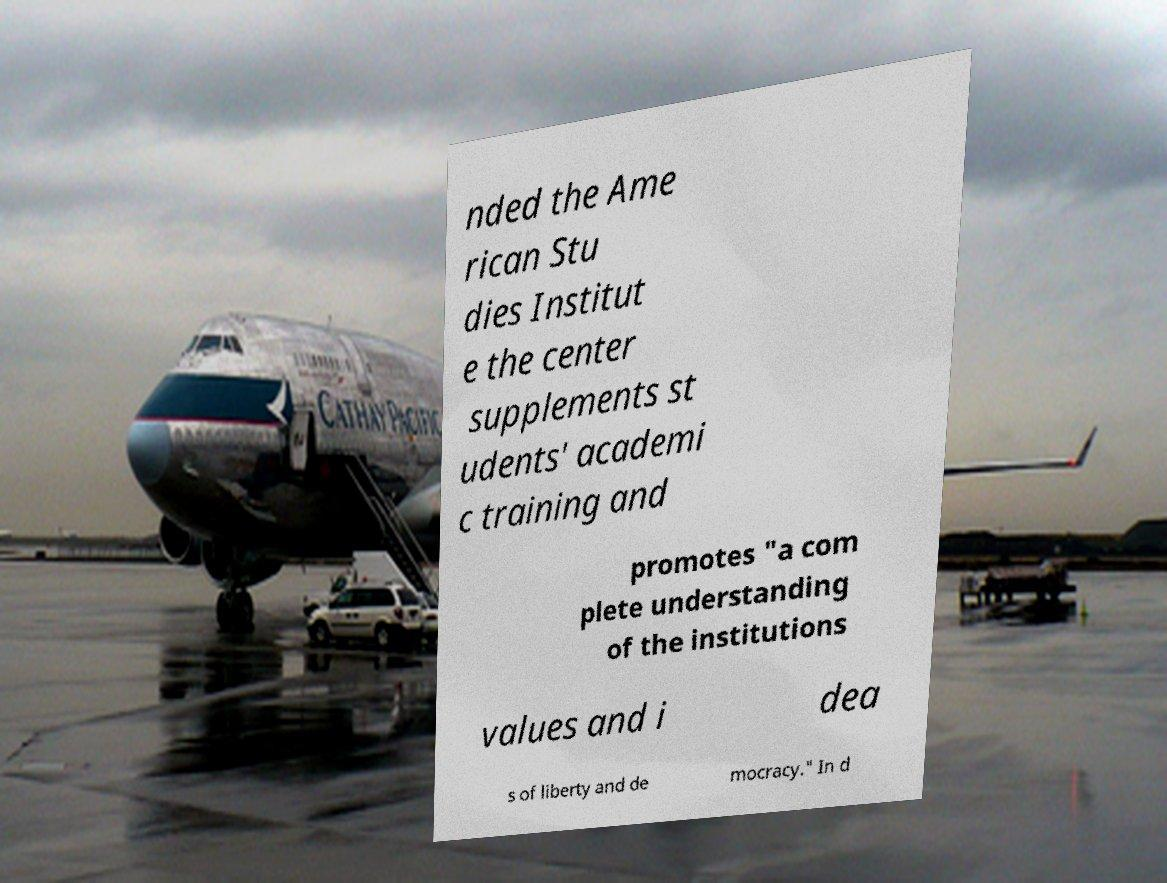Can you accurately transcribe the text from the provided image for me? nded the Ame rican Stu dies Institut e the center supplements st udents' academi c training and promotes "a com plete understanding of the institutions values and i dea s of liberty and de mocracy." In d 